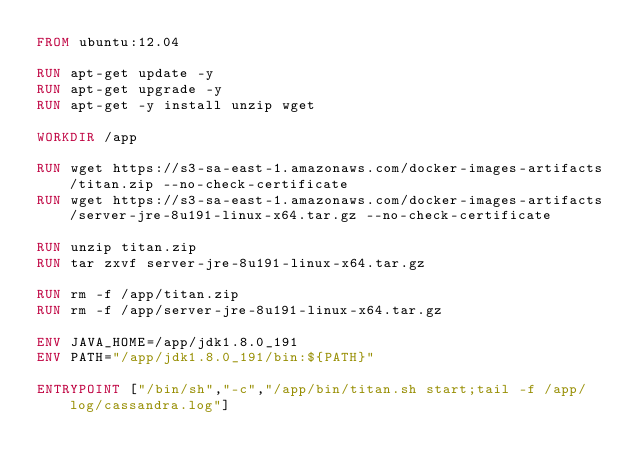<code> <loc_0><loc_0><loc_500><loc_500><_Dockerfile_>FROM ubuntu:12.04

RUN apt-get update -y
RUN apt-get upgrade -y
RUN apt-get -y install unzip wget

WORKDIR /app

RUN wget https://s3-sa-east-1.amazonaws.com/docker-images-artifacts/titan.zip --no-check-certificate
RUN wget https://s3-sa-east-1.amazonaws.com/docker-images-artifacts/server-jre-8u191-linux-x64.tar.gz --no-check-certificate

RUN unzip titan.zip
RUN tar zxvf server-jre-8u191-linux-x64.tar.gz

RUN rm -f /app/titan.zip
RUN rm -f /app/server-jre-8u191-linux-x64.tar.gz

ENV JAVA_HOME=/app/jdk1.8.0_191
ENV PATH="/app/jdk1.8.0_191/bin:${PATH}"

ENTRYPOINT ["/bin/sh","-c","/app/bin/titan.sh start;tail -f /app/log/cassandra.log"]
</code> 